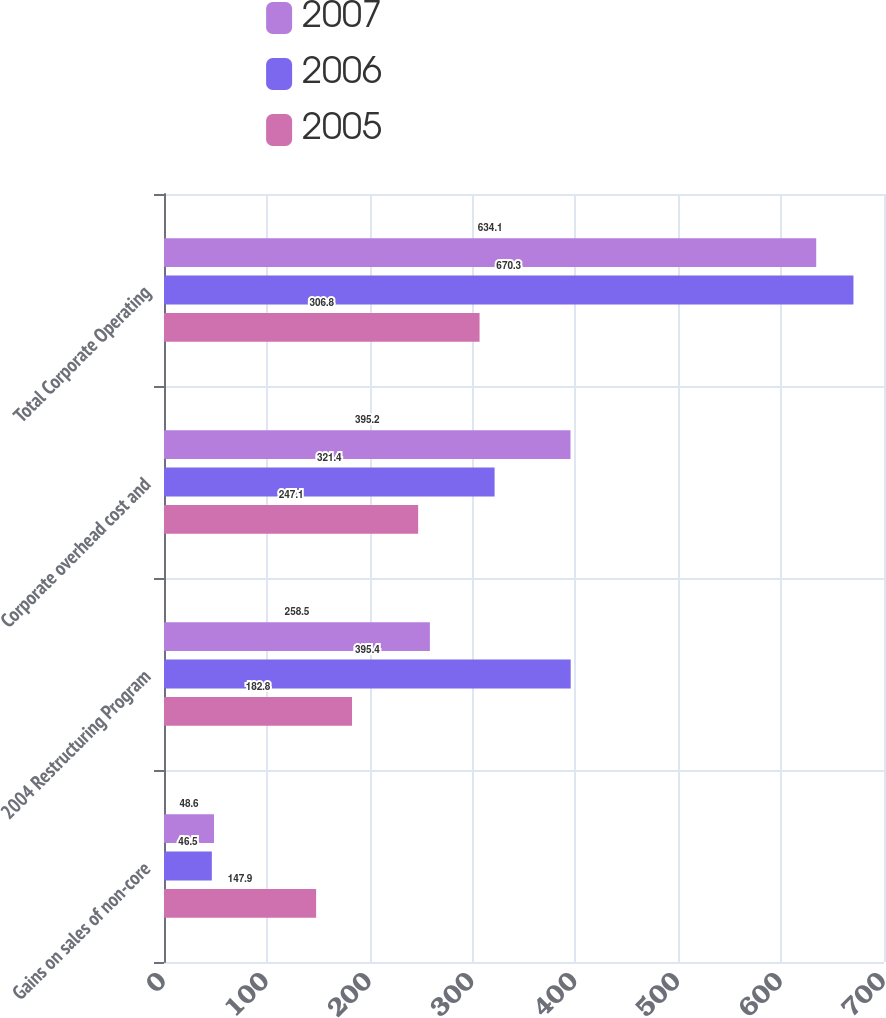<chart> <loc_0><loc_0><loc_500><loc_500><stacked_bar_chart><ecel><fcel>Gains on sales of non-core<fcel>2004 Restructuring Program<fcel>Corporate overhead cost and<fcel>Total Corporate Operating<nl><fcel>2007<fcel>48.6<fcel>258.5<fcel>395.2<fcel>634.1<nl><fcel>2006<fcel>46.5<fcel>395.4<fcel>321.4<fcel>670.3<nl><fcel>2005<fcel>147.9<fcel>182.8<fcel>247.1<fcel>306.8<nl></chart> 